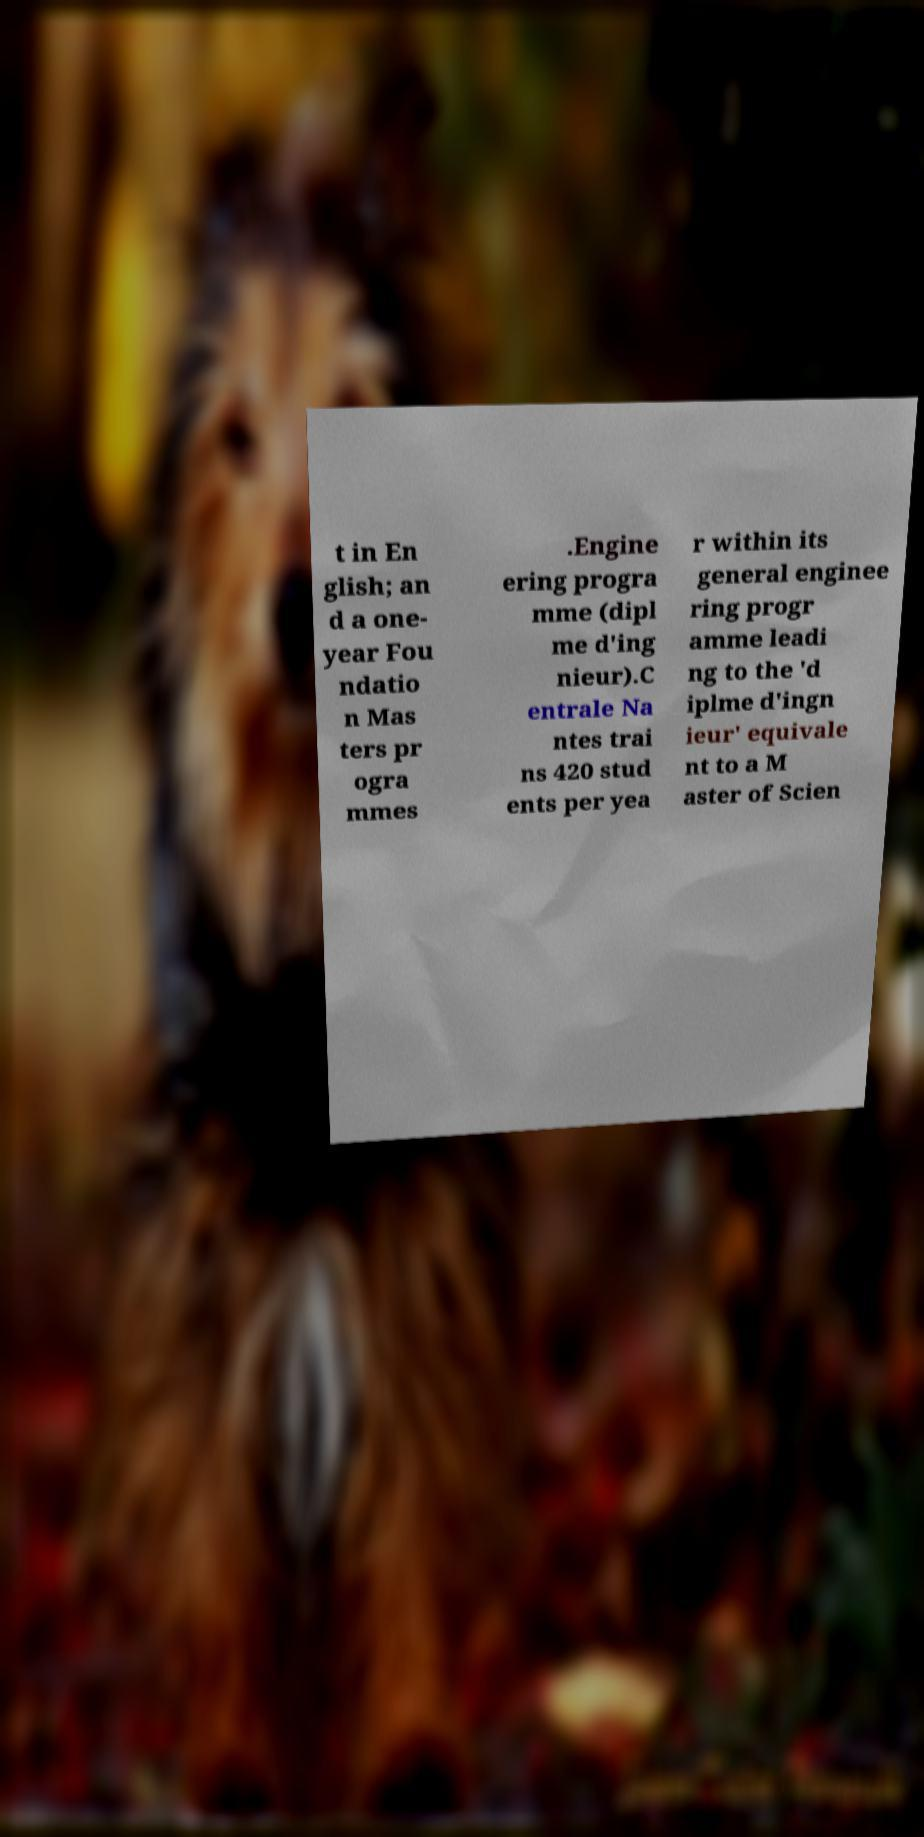There's text embedded in this image that I need extracted. Can you transcribe it verbatim? t in En glish; an d a one- year Fou ndatio n Mas ters pr ogra mmes .Engine ering progra mme (dipl me d'ing nieur).C entrale Na ntes trai ns 420 stud ents per yea r within its general enginee ring progr amme leadi ng to the 'd iplme d'ingn ieur' equivale nt to a M aster of Scien 